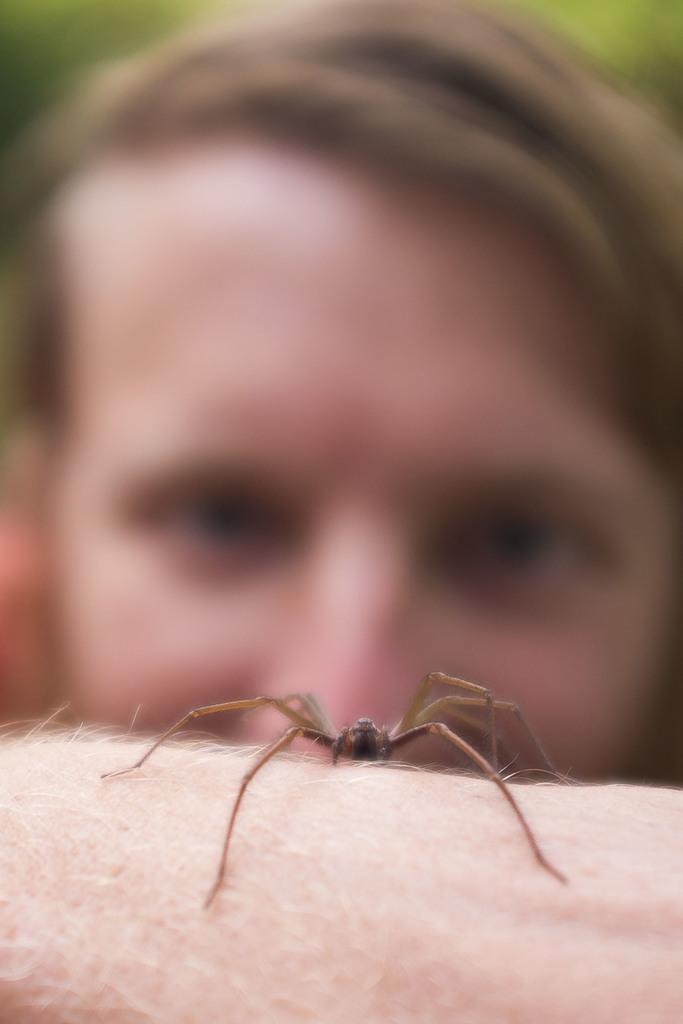What is the main subject of the image? The main subject of the image is a spider on a human body. Can you describe the secondary subject in the image? There is a blurred person's face in the background of the image. How many frogs can be seen hopping in the distance in the image? There are no frogs visible in the image. Is there a baby present in the image? There is no baby present in the image. 